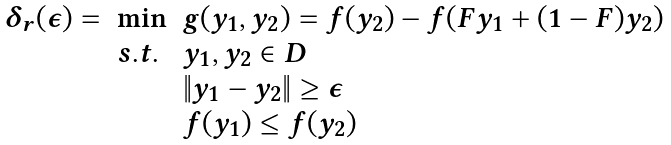Convert formula to latex. <formula><loc_0><loc_0><loc_500><loc_500>\begin{array} { l l l } \delta _ { r } ( \epsilon ) = & \min & g ( y _ { 1 } , y _ { 2 } ) = f ( y _ { 2 } ) - f ( F y _ { 1 } + ( 1 - F ) y _ { 2 } ) \\ & s . t . & y _ { 1 } , y _ { 2 } \in D \\ & & \| y _ { 1 } - y _ { 2 } \| \geq \epsilon \\ & & f ( y _ { 1 } ) \leq f ( y _ { 2 } ) \\ \end{array}</formula> 